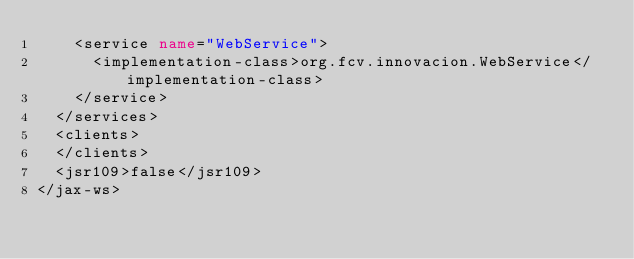Convert code to text. <code><loc_0><loc_0><loc_500><loc_500><_XML_>    <service name="WebService">
      <implementation-class>org.fcv.innovacion.WebService</implementation-class>
    </service>
  </services>
  <clients>
  </clients>
  <jsr109>false</jsr109>
</jax-ws>
</code> 